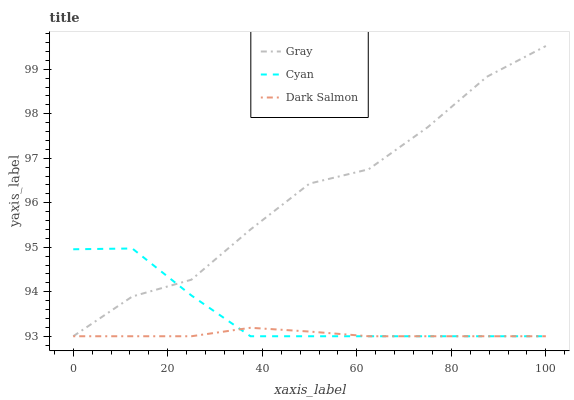Does Dark Salmon have the minimum area under the curve?
Answer yes or no. Yes. Does Gray have the maximum area under the curve?
Answer yes or no. Yes. Does Cyan have the minimum area under the curve?
Answer yes or no. No. Does Cyan have the maximum area under the curve?
Answer yes or no. No. Is Dark Salmon the smoothest?
Answer yes or no. Yes. Is Gray the roughest?
Answer yes or no. Yes. Is Cyan the smoothest?
Answer yes or no. No. Is Cyan the roughest?
Answer yes or no. No. Does Gray have the lowest value?
Answer yes or no. Yes. Does Gray have the highest value?
Answer yes or no. Yes. Does Cyan have the highest value?
Answer yes or no. No. Does Dark Salmon intersect Gray?
Answer yes or no. Yes. Is Dark Salmon less than Gray?
Answer yes or no. No. Is Dark Salmon greater than Gray?
Answer yes or no. No. 